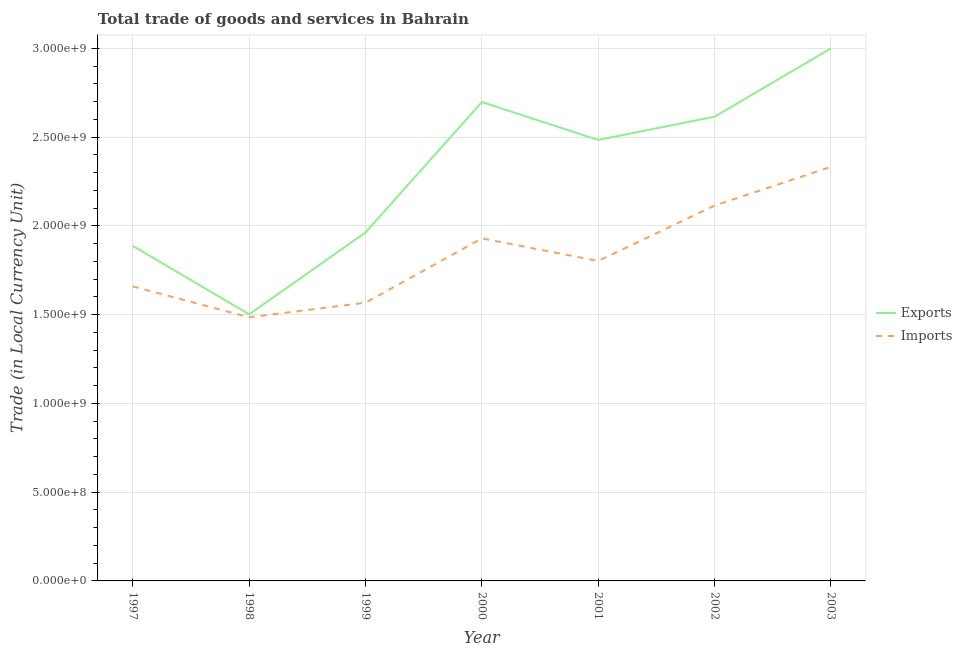What is the export of goods and services in 2003?
Your answer should be compact. 3.00e+09. Across all years, what is the maximum export of goods and services?
Your response must be concise. 3.00e+09. Across all years, what is the minimum export of goods and services?
Your answer should be compact. 1.50e+09. What is the total imports of goods and services in the graph?
Offer a very short reply. 1.29e+1. What is the difference between the export of goods and services in 1997 and that in 2003?
Keep it short and to the point. -1.11e+09. What is the difference between the export of goods and services in 2001 and the imports of goods and services in 2000?
Provide a short and direct response. 5.55e+08. What is the average imports of goods and services per year?
Your answer should be very brief. 1.84e+09. In the year 1997, what is the difference between the imports of goods and services and export of goods and services?
Give a very brief answer. -2.29e+08. What is the ratio of the export of goods and services in 2000 to that in 2002?
Offer a very short reply. 1.03. Is the export of goods and services in 1998 less than that in 2000?
Give a very brief answer. Yes. What is the difference between the highest and the second highest imports of goods and services?
Make the answer very short. 2.18e+08. What is the difference between the highest and the lowest export of goods and services?
Keep it short and to the point. 1.50e+09. Is the sum of the imports of goods and services in 2000 and 2002 greater than the maximum export of goods and services across all years?
Ensure brevity in your answer.  Yes. Does the imports of goods and services monotonically increase over the years?
Give a very brief answer. No. How many lines are there?
Provide a short and direct response. 2. What is the difference between two consecutive major ticks on the Y-axis?
Your answer should be very brief. 5.00e+08. Are the values on the major ticks of Y-axis written in scientific E-notation?
Make the answer very short. Yes. Does the graph contain grids?
Your answer should be compact. Yes. How many legend labels are there?
Your answer should be very brief. 2. What is the title of the graph?
Give a very brief answer. Total trade of goods and services in Bahrain. What is the label or title of the X-axis?
Your response must be concise. Year. What is the label or title of the Y-axis?
Give a very brief answer. Trade (in Local Currency Unit). What is the Trade (in Local Currency Unit) in Exports in 1997?
Provide a short and direct response. 1.89e+09. What is the Trade (in Local Currency Unit) in Imports in 1997?
Keep it short and to the point. 1.66e+09. What is the Trade (in Local Currency Unit) of Exports in 1998?
Ensure brevity in your answer.  1.50e+09. What is the Trade (in Local Currency Unit) in Imports in 1998?
Your response must be concise. 1.49e+09. What is the Trade (in Local Currency Unit) of Exports in 1999?
Offer a very short reply. 1.96e+09. What is the Trade (in Local Currency Unit) in Imports in 1999?
Offer a terse response. 1.57e+09. What is the Trade (in Local Currency Unit) in Exports in 2000?
Your response must be concise. 2.70e+09. What is the Trade (in Local Currency Unit) of Imports in 2000?
Keep it short and to the point. 1.93e+09. What is the Trade (in Local Currency Unit) of Exports in 2001?
Ensure brevity in your answer.  2.48e+09. What is the Trade (in Local Currency Unit) in Imports in 2001?
Ensure brevity in your answer.  1.80e+09. What is the Trade (in Local Currency Unit) in Exports in 2002?
Provide a short and direct response. 2.62e+09. What is the Trade (in Local Currency Unit) in Imports in 2002?
Provide a short and direct response. 2.11e+09. What is the Trade (in Local Currency Unit) of Exports in 2003?
Provide a short and direct response. 3.00e+09. What is the Trade (in Local Currency Unit) in Imports in 2003?
Ensure brevity in your answer.  2.33e+09. Across all years, what is the maximum Trade (in Local Currency Unit) of Exports?
Provide a succinct answer. 3.00e+09. Across all years, what is the maximum Trade (in Local Currency Unit) of Imports?
Offer a very short reply. 2.33e+09. Across all years, what is the minimum Trade (in Local Currency Unit) in Exports?
Make the answer very short. 1.50e+09. Across all years, what is the minimum Trade (in Local Currency Unit) in Imports?
Keep it short and to the point. 1.49e+09. What is the total Trade (in Local Currency Unit) in Exports in the graph?
Provide a succinct answer. 1.62e+1. What is the total Trade (in Local Currency Unit) of Imports in the graph?
Your response must be concise. 1.29e+1. What is the difference between the Trade (in Local Currency Unit) in Exports in 1997 and that in 1998?
Offer a terse response. 3.86e+08. What is the difference between the Trade (in Local Currency Unit) in Imports in 1997 and that in 1998?
Your response must be concise. 1.74e+08. What is the difference between the Trade (in Local Currency Unit) of Exports in 1997 and that in 1999?
Offer a terse response. -7.56e+07. What is the difference between the Trade (in Local Currency Unit) of Imports in 1997 and that in 1999?
Your response must be concise. 9.18e+07. What is the difference between the Trade (in Local Currency Unit) of Exports in 1997 and that in 2000?
Your answer should be compact. -8.10e+08. What is the difference between the Trade (in Local Currency Unit) of Imports in 1997 and that in 2000?
Your answer should be very brief. -2.70e+08. What is the difference between the Trade (in Local Currency Unit) of Exports in 1997 and that in 2001?
Your answer should be compact. -5.97e+08. What is the difference between the Trade (in Local Currency Unit) of Imports in 1997 and that in 2001?
Offer a very short reply. -1.44e+08. What is the difference between the Trade (in Local Currency Unit) of Exports in 1997 and that in 2002?
Your answer should be very brief. -7.28e+08. What is the difference between the Trade (in Local Currency Unit) in Imports in 1997 and that in 2002?
Give a very brief answer. -4.55e+08. What is the difference between the Trade (in Local Currency Unit) in Exports in 1997 and that in 2003?
Offer a terse response. -1.11e+09. What is the difference between the Trade (in Local Currency Unit) in Imports in 1997 and that in 2003?
Give a very brief answer. -6.74e+08. What is the difference between the Trade (in Local Currency Unit) of Exports in 1998 and that in 1999?
Your response must be concise. -4.61e+08. What is the difference between the Trade (in Local Currency Unit) in Imports in 1998 and that in 1999?
Provide a succinct answer. -8.21e+07. What is the difference between the Trade (in Local Currency Unit) in Exports in 1998 and that in 2000?
Offer a very short reply. -1.20e+09. What is the difference between the Trade (in Local Currency Unit) of Imports in 1998 and that in 2000?
Your answer should be very brief. -4.44e+08. What is the difference between the Trade (in Local Currency Unit) of Exports in 1998 and that in 2001?
Your answer should be very brief. -9.82e+08. What is the difference between the Trade (in Local Currency Unit) of Imports in 1998 and that in 2001?
Provide a succinct answer. -3.17e+08. What is the difference between the Trade (in Local Currency Unit) of Exports in 1998 and that in 2002?
Give a very brief answer. -1.11e+09. What is the difference between the Trade (in Local Currency Unit) of Imports in 1998 and that in 2002?
Ensure brevity in your answer.  -6.29e+08. What is the difference between the Trade (in Local Currency Unit) of Exports in 1998 and that in 2003?
Your response must be concise. -1.50e+09. What is the difference between the Trade (in Local Currency Unit) in Imports in 1998 and that in 2003?
Your answer should be very brief. -8.48e+08. What is the difference between the Trade (in Local Currency Unit) of Exports in 1999 and that in 2000?
Your answer should be compact. -7.35e+08. What is the difference between the Trade (in Local Currency Unit) in Imports in 1999 and that in 2000?
Provide a short and direct response. -3.62e+08. What is the difference between the Trade (in Local Currency Unit) in Exports in 1999 and that in 2001?
Provide a short and direct response. -5.21e+08. What is the difference between the Trade (in Local Currency Unit) in Imports in 1999 and that in 2001?
Offer a terse response. -2.35e+08. What is the difference between the Trade (in Local Currency Unit) in Exports in 1999 and that in 2002?
Your answer should be very brief. -6.52e+08. What is the difference between the Trade (in Local Currency Unit) of Imports in 1999 and that in 2002?
Make the answer very short. -5.47e+08. What is the difference between the Trade (in Local Currency Unit) of Exports in 1999 and that in 2003?
Your response must be concise. -1.04e+09. What is the difference between the Trade (in Local Currency Unit) of Imports in 1999 and that in 2003?
Provide a short and direct response. -7.66e+08. What is the difference between the Trade (in Local Currency Unit) in Exports in 2000 and that in 2001?
Make the answer very short. 2.14e+08. What is the difference between the Trade (in Local Currency Unit) of Imports in 2000 and that in 2001?
Keep it short and to the point. 1.27e+08. What is the difference between the Trade (in Local Currency Unit) of Exports in 2000 and that in 2002?
Your answer should be compact. 8.27e+07. What is the difference between the Trade (in Local Currency Unit) in Imports in 2000 and that in 2002?
Provide a short and direct response. -1.85e+08. What is the difference between the Trade (in Local Currency Unit) of Exports in 2000 and that in 2003?
Your response must be concise. -3.03e+08. What is the difference between the Trade (in Local Currency Unit) in Imports in 2000 and that in 2003?
Make the answer very short. -4.03e+08. What is the difference between the Trade (in Local Currency Unit) in Exports in 2001 and that in 2002?
Keep it short and to the point. -1.31e+08. What is the difference between the Trade (in Local Currency Unit) in Imports in 2001 and that in 2002?
Your answer should be very brief. -3.12e+08. What is the difference between the Trade (in Local Currency Unit) of Exports in 2001 and that in 2003?
Offer a very short reply. -5.16e+08. What is the difference between the Trade (in Local Currency Unit) of Imports in 2001 and that in 2003?
Provide a succinct answer. -5.30e+08. What is the difference between the Trade (in Local Currency Unit) in Exports in 2002 and that in 2003?
Your response must be concise. -3.85e+08. What is the difference between the Trade (in Local Currency Unit) in Imports in 2002 and that in 2003?
Make the answer very short. -2.18e+08. What is the difference between the Trade (in Local Currency Unit) of Exports in 1997 and the Trade (in Local Currency Unit) of Imports in 1998?
Your answer should be very brief. 4.02e+08. What is the difference between the Trade (in Local Currency Unit) of Exports in 1997 and the Trade (in Local Currency Unit) of Imports in 1999?
Your response must be concise. 3.20e+08. What is the difference between the Trade (in Local Currency Unit) of Exports in 1997 and the Trade (in Local Currency Unit) of Imports in 2000?
Ensure brevity in your answer.  -4.19e+07. What is the difference between the Trade (in Local Currency Unit) in Exports in 1997 and the Trade (in Local Currency Unit) in Imports in 2001?
Give a very brief answer. 8.50e+07. What is the difference between the Trade (in Local Currency Unit) in Exports in 1997 and the Trade (in Local Currency Unit) in Imports in 2002?
Your response must be concise. -2.27e+08. What is the difference between the Trade (in Local Currency Unit) of Exports in 1997 and the Trade (in Local Currency Unit) of Imports in 2003?
Your answer should be compact. -4.45e+08. What is the difference between the Trade (in Local Currency Unit) in Exports in 1998 and the Trade (in Local Currency Unit) in Imports in 1999?
Make the answer very short. -6.54e+07. What is the difference between the Trade (in Local Currency Unit) in Exports in 1998 and the Trade (in Local Currency Unit) in Imports in 2000?
Offer a very short reply. -4.28e+08. What is the difference between the Trade (in Local Currency Unit) of Exports in 1998 and the Trade (in Local Currency Unit) of Imports in 2001?
Provide a succinct answer. -3.01e+08. What is the difference between the Trade (in Local Currency Unit) of Exports in 1998 and the Trade (in Local Currency Unit) of Imports in 2002?
Your answer should be very brief. -6.13e+08. What is the difference between the Trade (in Local Currency Unit) in Exports in 1998 and the Trade (in Local Currency Unit) in Imports in 2003?
Offer a very short reply. -8.31e+08. What is the difference between the Trade (in Local Currency Unit) in Exports in 1999 and the Trade (in Local Currency Unit) in Imports in 2000?
Give a very brief answer. 3.37e+07. What is the difference between the Trade (in Local Currency Unit) of Exports in 1999 and the Trade (in Local Currency Unit) of Imports in 2001?
Offer a terse response. 1.61e+08. What is the difference between the Trade (in Local Currency Unit) of Exports in 1999 and the Trade (in Local Currency Unit) of Imports in 2002?
Make the answer very short. -1.51e+08. What is the difference between the Trade (in Local Currency Unit) of Exports in 1999 and the Trade (in Local Currency Unit) of Imports in 2003?
Provide a short and direct response. -3.70e+08. What is the difference between the Trade (in Local Currency Unit) of Exports in 2000 and the Trade (in Local Currency Unit) of Imports in 2001?
Ensure brevity in your answer.  8.95e+08. What is the difference between the Trade (in Local Currency Unit) of Exports in 2000 and the Trade (in Local Currency Unit) of Imports in 2002?
Your response must be concise. 5.84e+08. What is the difference between the Trade (in Local Currency Unit) of Exports in 2000 and the Trade (in Local Currency Unit) of Imports in 2003?
Your response must be concise. 3.65e+08. What is the difference between the Trade (in Local Currency Unit) in Exports in 2001 and the Trade (in Local Currency Unit) in Imports in 2002?
Keep it short and to the point. 3.70e+08. What is the difference between the Trade (in Local Currency Unit) of Exports in 2001 and the Trade (in Local Currency Unit) of Imports in 2003?
Keep it short and to the point. 1.51e+08. What is the difference between the Trade (in Local Currency Unit) of Exports in 2002 and the Trade (in Local Currency Unit) of Imports in 2003?
Your answer should be very brief. 2.82e+08. What is the average Trade (in Local Currency Unit) of Exports per year?
Provide a succinct answer. 2.31e+09. What is the average Trade (in Local Currency Unit) in Imports per year?
Your answer should be very brief. 1.84e+09. In the year 1997, what is the difference between the Trade (in Local Currency Unit) in Exports and Trade (in Local Currency Unit) in Imports?
Your answer should be very brief. 2.29e+08. In the year 1998, what is the difference between the Trade (in Local Currency Unit) in Exports and Trade (in Local Currency Unit) in Imports?
Provide a succinct answer. 1.67e+07. In the year 1999, what is the difference between the Trade (in Local Currency Unit) of Exports and Trade (in Local Currency Unit) of Imports?
Your answer should be compact. 3.96e+08. In the year 2000, what is the difference between the Trade (in Local Currency Unit) in Exports and Trade (in Local Currency Unit) in Imports?
Offer a very short reply. 7.68e+08. In the year 2001, what is the difference between the Trade (in Local Currency Unit) in Exports and Trade (in Local Currency Unit) in Imports?
Offer a terse response. 6.82e+08. In the year 2002, what is the difference between the Trade (in Local Currency Unit) in Exports and Trade (in Local Currency Unit) in Imports?
Give a very brief answer. 5.01e+08. In the year 2003, what is the difference between the Trade (in Local Currency Unit) of Exports and Trade (in Local Currency Unit) of Imports?
Your answer should be compact. 6.68e+08. What is the ratio of the Trade (in Local Currency Unit) in Exports in 1997 to that in 1998?
Your response must be concise. 1.26. What is the ratio of the Trade (in Local Currency Unit) in Imports in 1997 to that in 1998?
Your answer should be compact. 1.12. What is the ratio of the Trade (in Local Currency Unit) of Exports in 1997 to that in 1999?
Provide a short and direct response. 0.96. What is the ratio of the Trade (in Local Currency Unit) in Imports in 1997 to that in 1999?
Give a very brief answer. 1.06. What is the ratio of the Trade (in Local Currency Unit) of Exports in 1997 to that in 2000?
Your answer should be compact. 0.7. What is the ratio of the Trade (in Local Currency Unit) of Imports in 1997 to that in 2000?
Provide a succinct answer. 0.86. What is the ratio of the Trade (in Local Currency Unit) in Exports in 1997 to that in 2001?
Your answer should be compact. 0.76. What is the ratio of the Trade (in Local Currency Unit) in Imports in 1997 to that in 2001?
Make the answer very short. 0.92. What is the ratio of the Trade (in Local Currency Unit) of Exports in 1997 to that in 2002?
Your answer should be compact. 0.72. What is the ratio of the Trade (in Local Currency Unit) in Imports in 1997 to that in 2002?
Keep it short and to the point. 0.78. What is the ratio of the Trade (in Local Currency Unit) in Exports in 1997 to that in 2003?
Ensure brevity in your answer.  0.63. What is the ratio of the Trade (in Local Currency Unit) in Imports in 1997 to that in 2003?
Your response must be concise. 0.71. What is the ratio of the Trade (in Local Currency Unit) of Exports in 1998 to that in 1999?
Make the answer very short. 0.77. What is the ratio of the Trade (in Local Currency Unit) of Imports in 1998 to that in 1999?
Keep it short and to the point. 0.95. What is the ratio of the Trade (in Local Currency Unit) in Exports in 1998 to that in 2000?
Your answer should be very brief. 0.56. What is the ratio of the Trade (in Local Currency Unit) in Imports in 1998 to that in 2000?
Ensure brevity in your answer.  0.77. What is the ratio of the Trade (in Local Currency Unit) of Exports in 1998 to that in 2001?
Offer a terse response. 0.6. What is the ratio of the Trade (in Local Currency Unit) of Imports in 1998 to that in 2001?
Give a very brief answer. 0.82. What is the ratio of the Trade (in Local Currency Unit) in Exports in 1998 to that in 2002?
Provide a short and direct response. 0.57. What is the ratio of the Trade (in Local Currency Unit) of Imports in 1998 to that in 2002?
Make the answer very short. 0.7. What is the ratio of the Trade (in Local Currency Unit) in Exports in 1998 to that in 2003?
Make the answer very short. 0.5. What is the ratio of the Trade (in Local Currency Unit) of Imports in 1998 to that in 2003?
Offer a very short reply. 0.64. What is the ratio of the Trade (in Local Currency Unit) of Exports in 1999 to that in 2000?
Make the answer very short. 0.73. What is the ratio of the Trade (in Local Currency Unit) of Imports in 1999 to that in 2000?
Ensure brevity in your answer.  0.81. What is the ratio of the Trade (in Local Currency Unit) of Exports in 1999 to that in 2001?
Offer a terse response. 0.79. What is the ratio of the Trade (in Local Currency Unit) of Imports in 1999 to that in 2001?
Give a very brief answer. 0.87. What is the ratio of the Trade (in Local Currency Unit) of Exports in 1999 to that in 2002?
Keep it short and to the point. 0.75. What is the ratio of the Trade (in Local Currency Unit) of Imports in 1999 to that in 2002?
Provide a short and direct response. 0.74. What is the ratio of the Trade (in Local Currency Unit) in Exports in 1999 to that in 2003?
Make the answer very short. 0.65. What is the ratio of the Trade (in Local Currency Unit) of Imports in 1999 to that in 2003?
Your response must be concise. 0.67. What is the ratio of the Trade (in Local Currency Unit) of Exports in 2000 to that in 2001?
Provide a short and direct response. 1.09. What is the ratio of the Trade (in Local Currency Unit) in Imports in 2000 to that in 2001?
Keep it short and to the point. 1.07. What is the ratio of the Trade (in Local Currency Unit) of Exports in 2000 to that in 2002?
Your answer should be very brief. 1.03. What is the ratio of the Trade (in Local Currency Unit) in Imports in 2000 to that in 2002?
Keep it short and to the point. 0.91. What is the ratio of the Trade (in Local Currency Unit) of Exports in 2000 to that in 2003?
Your response must be concise. 0.9. What is the ratio of the Trade (in Local Currency Unit) of Imports in 2000 to that in 2003?
Make the answer very short. 0.83. What is the ratio of the Trade (in Local Currency Unit) of Exports in 2001 to that in 2002?
Provide a succinct answer. 0.95. What is the ratio of the Trade (in Local Currency Unit) in Imports in 2001 to that in 2002?
Offer a very short reply. 0.85. What is the ratio of the Trade (in Local Currency Unit) of Exports in 2001 to that in 2003?
Ensure brevity in your answer.  0.83. What is the ratio of the Trade (in Local Currency Unit) in Imports in 2001 to that in 2003?
Make the answer very short. 0.77. What is the ratio of the Trade (in Local Currency Unit) of Exports in 2002 to that in 2003?
Ensure brevity in your answer.  0.87. What is the ratio of the Trade (in Local Currency Unit) in Imports in 2002 to that in 2003?
Your answer should be very brief. 0.91. What is the difference between the highest and the second highest Trade (in Local Currency Unit) of Exports?
Provide a succinct answer. 3.03e+08. What is the difference between the highest and the second highest Trade (in Local Currency Unit) in Imports?
Provide a succinct answer. 2.18e+08. What is the difference between the highest and the lowest Trade (in Local Currency Unit) in Exports?
Your response must be concise. 1.50e+09. What is the difference between the highest and the lowest Trade (in Local Currency Unit) of Imports?
Provide a short and direct response. 8.48e+08. 